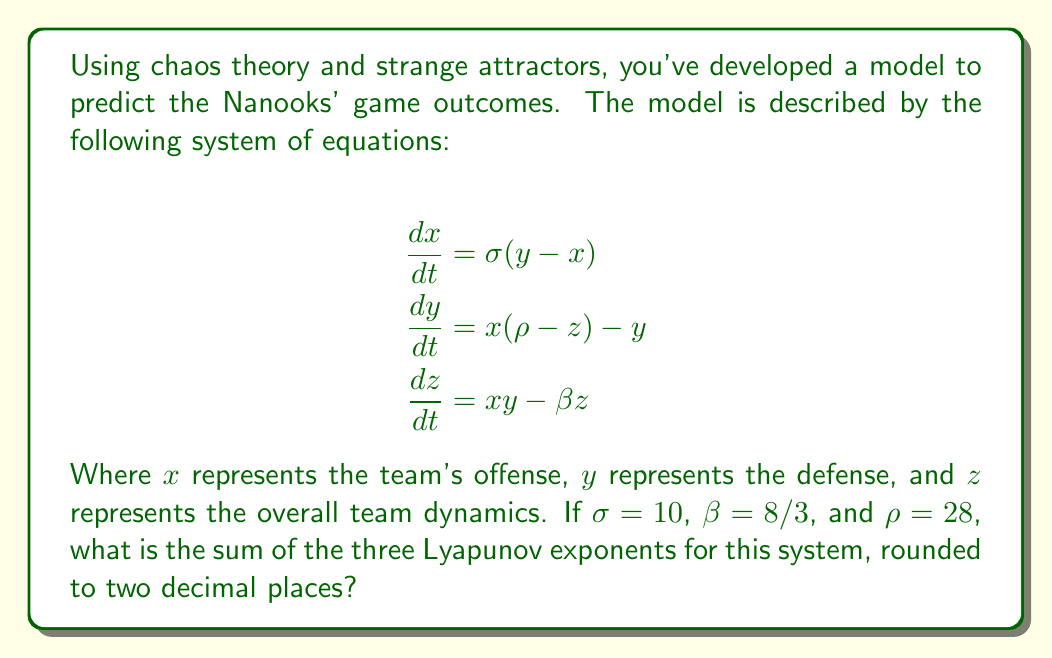Teach me how to tackle this problem. To solve this problem, we'll follow these steps:

1) First, recall that for a three-dimensional system like the Lorenz system (which is what we have here), the sum of the Lyapunov exponents is equal to the average divergence of the flow.

2) The divergence of the flow is given by the trace of the Jacobian matrix of the system.

3) Let's calculate the Jacobian matrix:

   $$J = \begin{bmatrix}
   \frac{\partial \dot{x}}{\partial x} & \frac{\partial \dot{x}}{\partial y} & \frac{\partial \dot{x}}{\partial z} \\
   \frac{\partial \dot{y}}{\partial x} & \frac{\partial \dot{y}}{\partial y} & \frac{\partial \dot{y}}{\partial z} \\
   \frac{\partial \dot{z}}{\partial x} & \frac{\partial \dot{z}}{\partial y} & \frac{\partial \dot{z}}{\partial z}
   \end{bmatrix}$$

4) Calculating each element:

   $$J = \begin{bmatrix}
   -\sigma & \sigma & 0 \\
   \rho - z & -1 & -x \\
   y & x & -\beta
   \end{bmatrix}$$

5) The trace of this matrix is the sum of the diagonal elements:

   $Tr(J) = -\sigma - 1 - \beta$

6) Substituting the given values:

   $Tr(J) = -10 - 1 - 8/3 = -41/3$

7) The average divergence is this value divided by the dimension of the system (which is 3):

   $\text{Average Divergence} = \frac{-41/3}{3} = -\frac{41}{9}$

8) This is equal to the sum of the Lyapunov exponents.

9) Converting to a decimal and rounding to two places:

   $-\frac{41}{9} \approx -4.56$

Therefore, the sum of the three Lyapunov exponents, rounded to two decimal places, is -4.56.
Answer: -4.56 